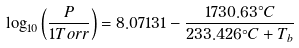Convert formula to latex. <formula><loc_0><loc_0><loc_500><loc_500>\log _ { 1 0 } \left ( { \frac { P } { 1 { T o r r } } } \right ) = 8 . 0 7 1 3 1 - { \frac { 1 7 3 0 . 6 3 ^ { \circ } { C } } { 2 3 3 . 4 2 6 ^ { \circ } { C } + T _ { b } } }</formula> 